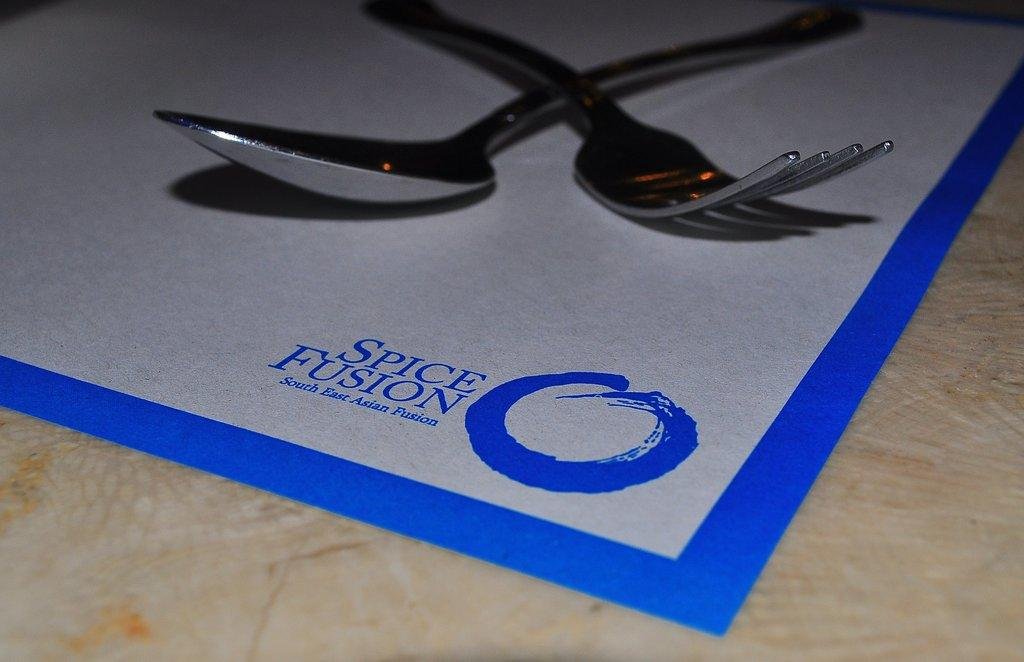What utensils are visible in the image? There is a spoon and a fork in the image. What color is the sheet on which the utensils are placed? The sheet is white in color. Where is the sheet located? The sheet is placed on a table. What additional detail can be observed on the sheet? There is text in blue color on the sheet. Can you see any toes in the image? There are no toes visible in the image. What type of lettuce is being used as a tablecloth in the image? There is no lettuce present in the image; it features a white sheet on a table. 